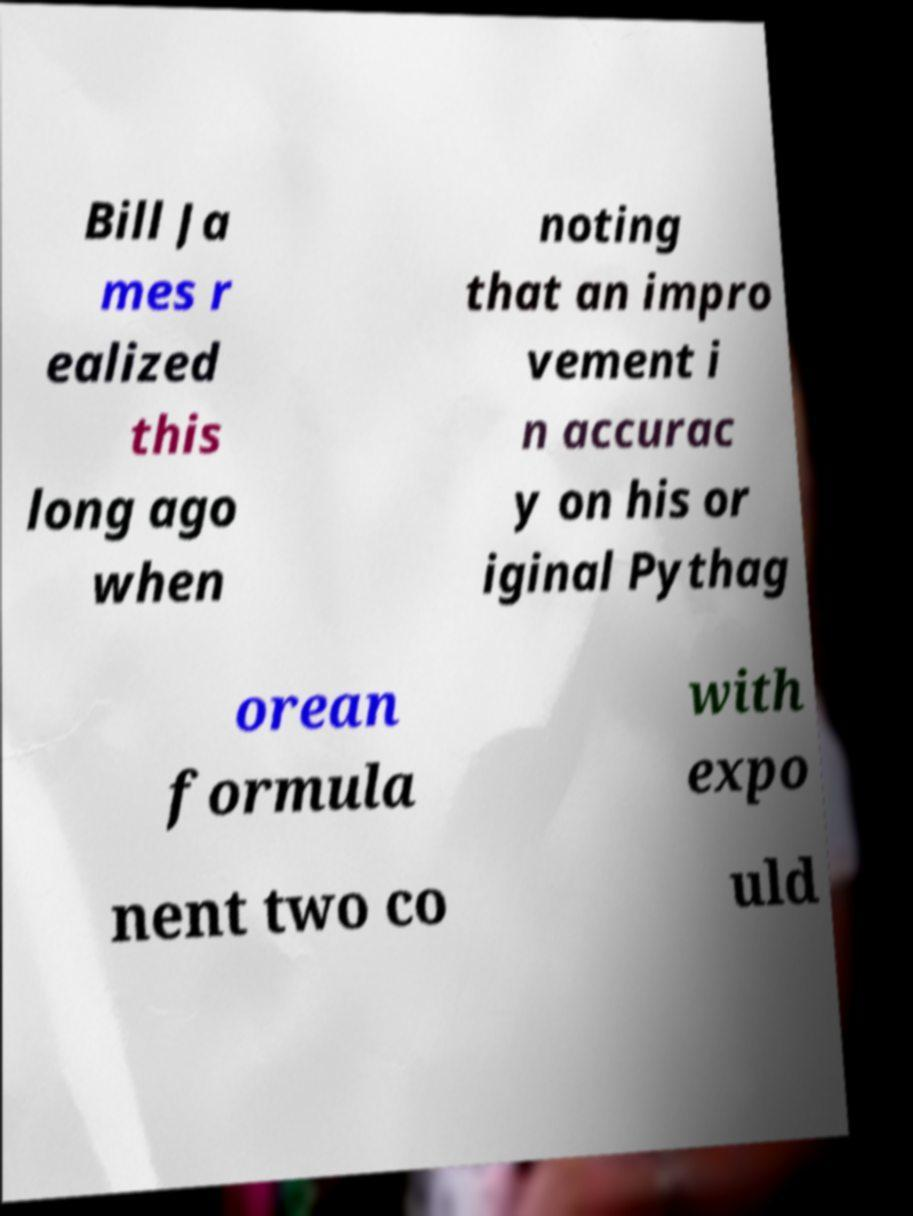For documentation purposes, I need the text within this image transcribed. Could you provide that? Bill Ja mes r ealized this long ago when noting that an impro vement i n accurac y on his or iginal Pythag orean formula with expo nent two co uld 